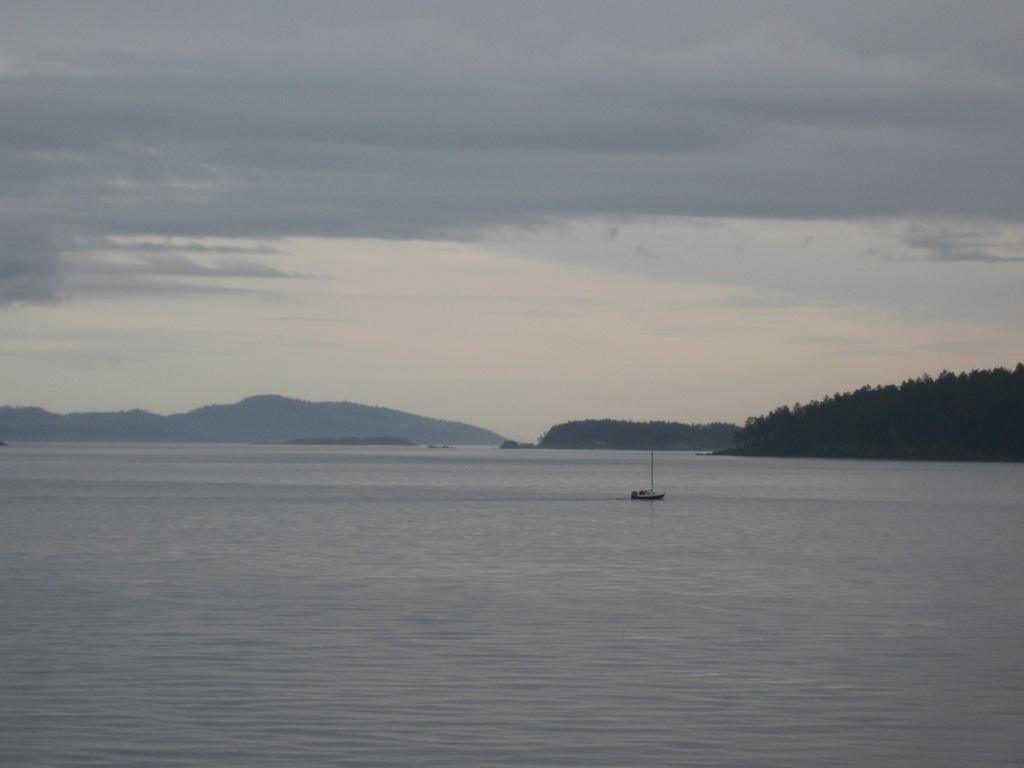Can you describe this image briefly? As we can see in the image there is water, boat, trees, hills, sky and clouds. 